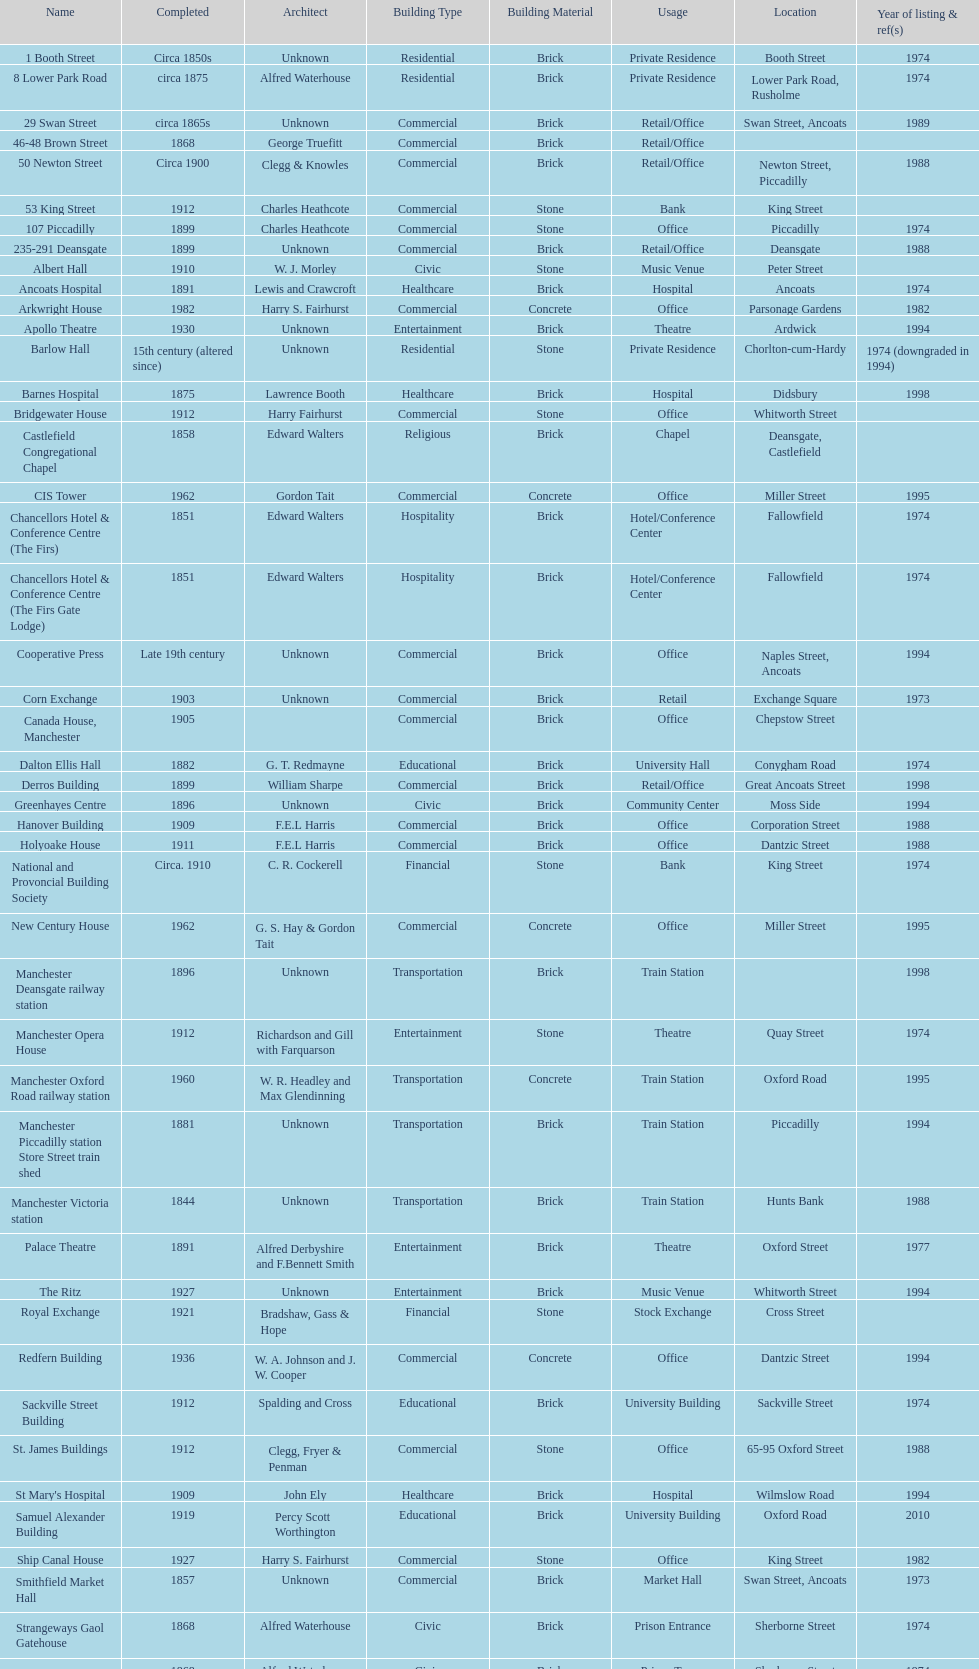Which year has the most buildings listed? 1974. 